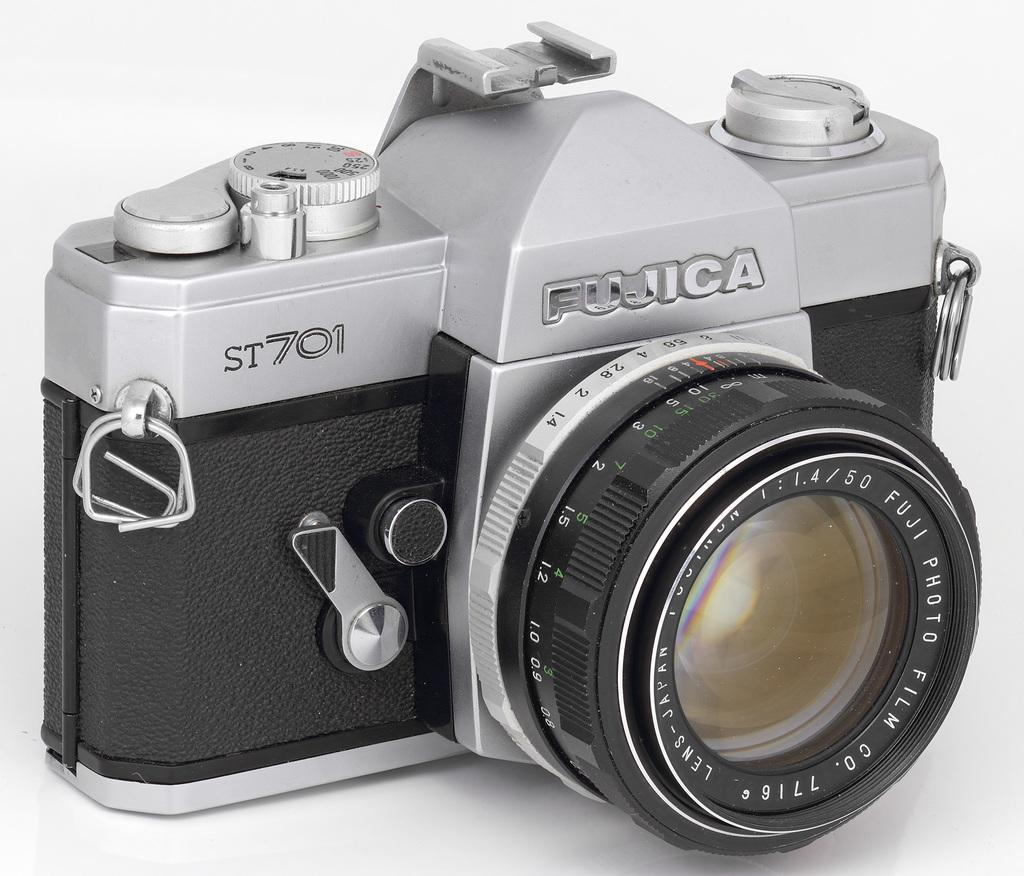<image>
Render a clear and concise summary of the photo. a fujica st701 camera, with the lens extended 